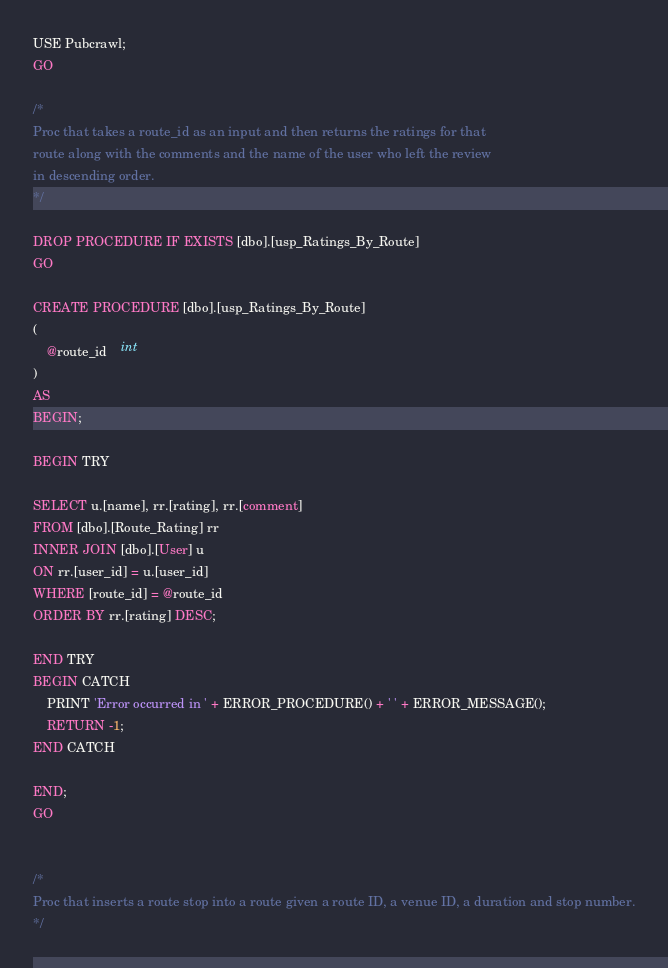Convert code to text. <code><loc_0><loc_0><loc_500><loc_500><_SQL_>USE Pubcrawl;
GO

/*
Proc that takes a route_id as an input and then returns the ratings for that 
route along with the comments and the name of the user who left the review
in descending order.
*/

DROP PROCEDURE IF EXISTS [dbo].[usp_Ratings_By_Route]
GO

CREATE PROCEDURE [dbo].[usp_Ratings_By_Route]
(
	@route_id	int
)
AS
BEGIN;

BEGIN TRY

SELECT u.[name], rr.[rating], rr.[comment] 
FROM [dbo].[Route_Rating] rr
INNER JOIN [dbo].[User] u
ON rr.[user_id] = u.[user_id]
WHERE [route_id] = @route_id
ORDER BY rr.[rating] DESC;

END TRY
BEGIN CATCH
	PRINT 'Error occurred in ' + ERROR_PROCEDURE() + ' ' + ERROR_MESSAGE();
	RETURN -1;
END CATCH

END;
GO


/*
Proc that inserts a route stop into a route given a route ID, a venue ID, a duration and stop number.
*/
</code> 